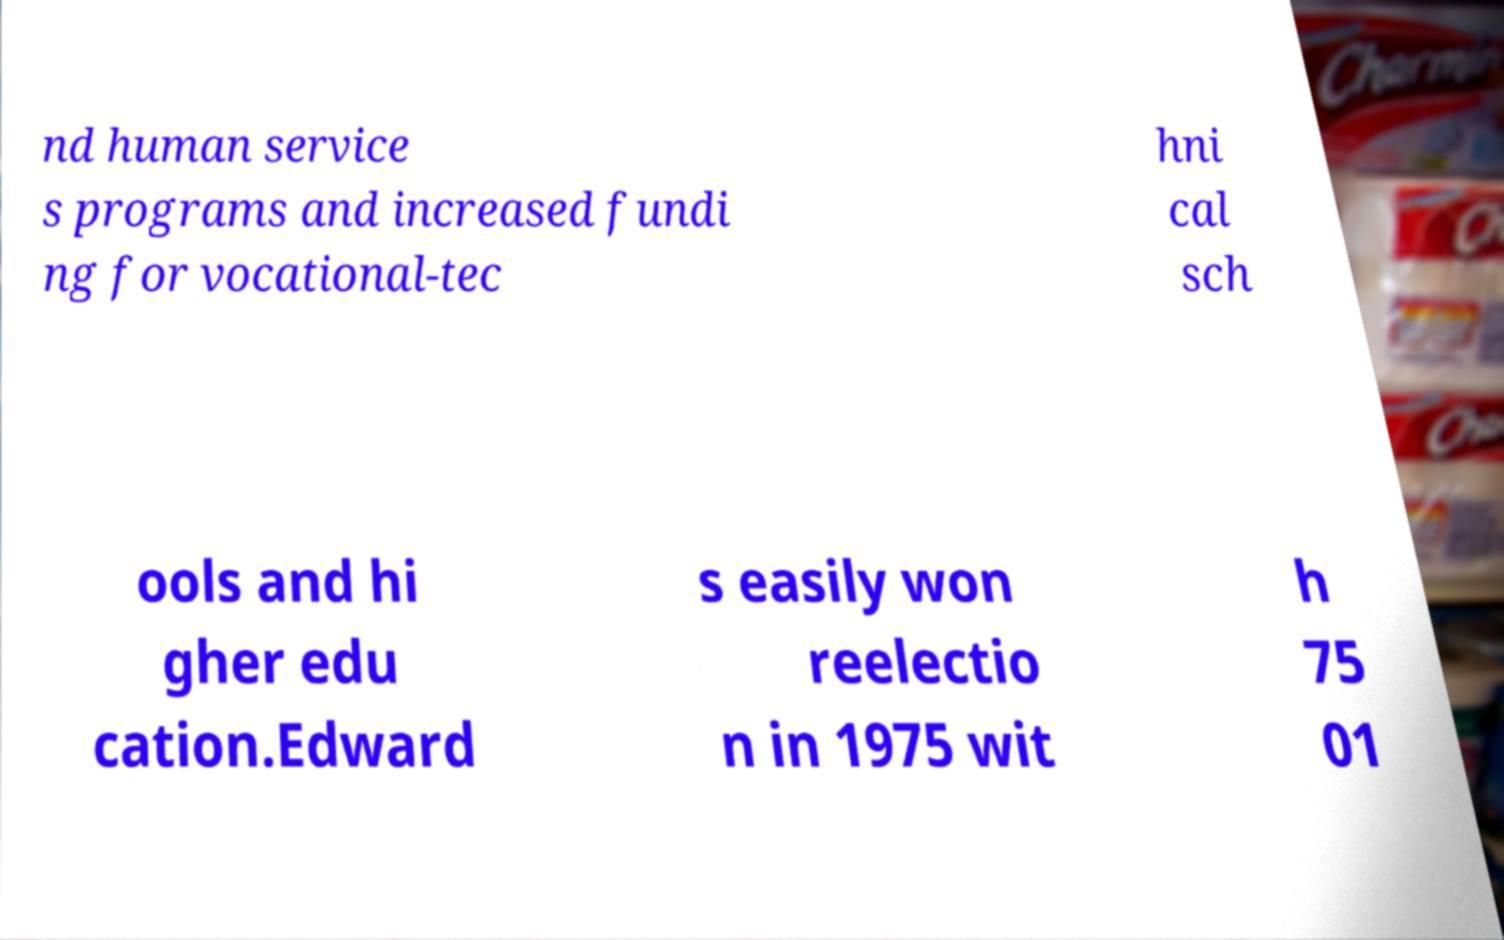Can you read and provide the text displayed in the image?This photo seems to have some interesting text. Can you extract and type it out for me? nd human service s programs and increased fundi ng for vocational-tec hni cal sch ools and hi gher edu cation.Edward s easily won reelectio n in 1975 wit h 75 01 